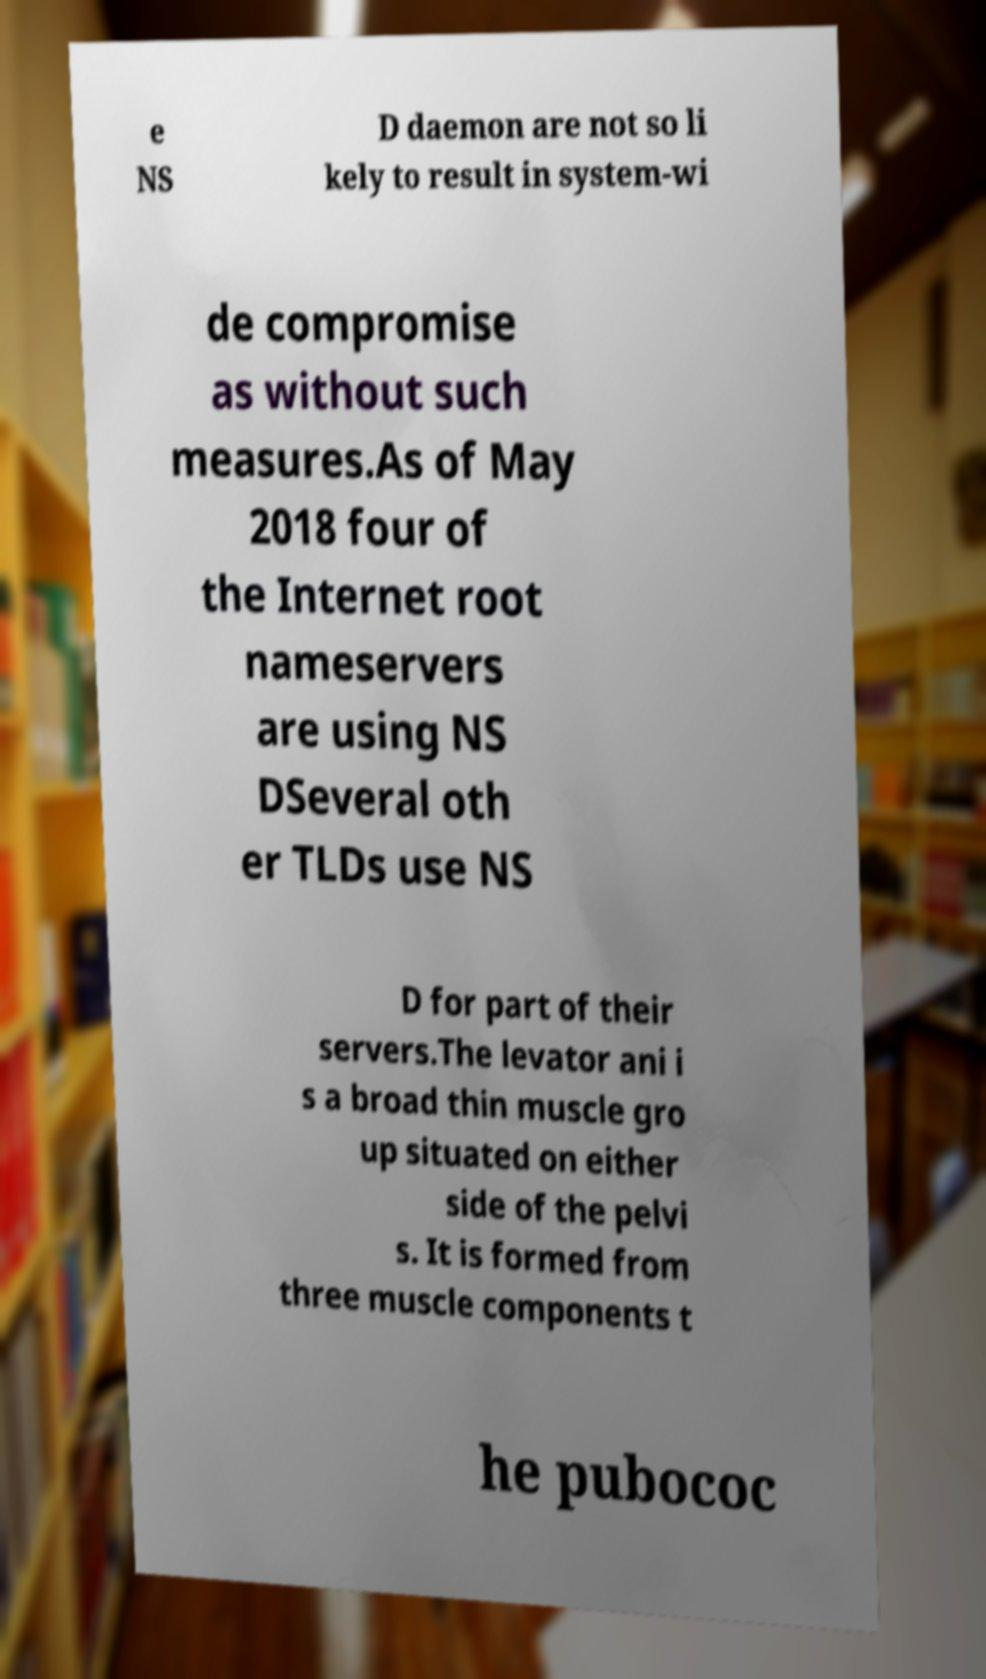There's text embedded in this image that I need extracted. Can you transcribe it verbatim? e NS D daemon are not so li kely to result in system-wi de compromise as without such measures.As of May 2018 four of the Internet root nameservers are using NS DSeveral oth er TLDs use NS D for part of their servers.The levator ani i s a broad thin muscle gro up situated on either side of the pelvi s. It is formed from three muscle components t he pubococ 